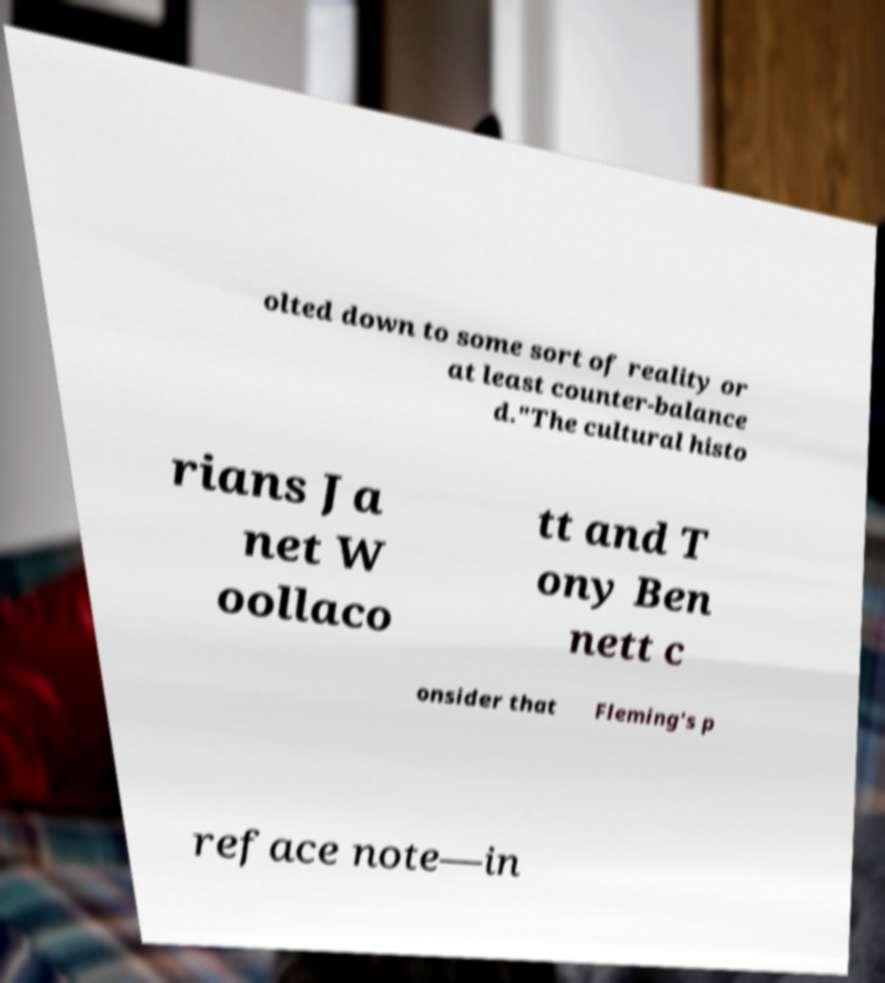For documentation purposes, I need the text within this image transcribed. Could you provide that? olted down to some sort of reality or at least counter-balance d."The cultural histo rians Ja net W oollaco tt and T ony Ben nett c onsider that Fleming's p reface note—in 